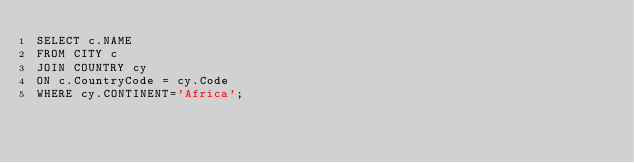<code> <loc_0><loc_0><loc_500><loc_500><_SQL_>SELECT c.NAME
FROM CITY c
JOIN COUNTRY cy
ON c.CountryCode = cy.Code
WHERE cy.CONTINENT='Africa';</code> 